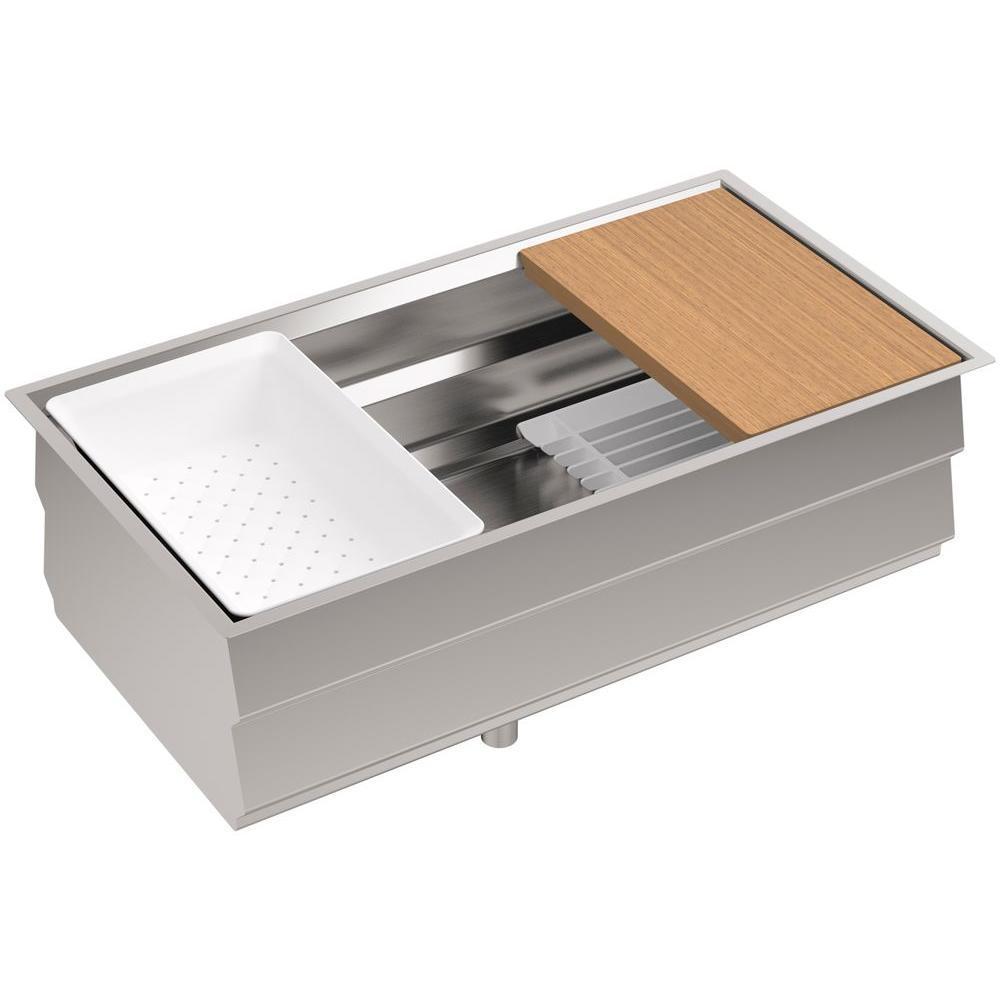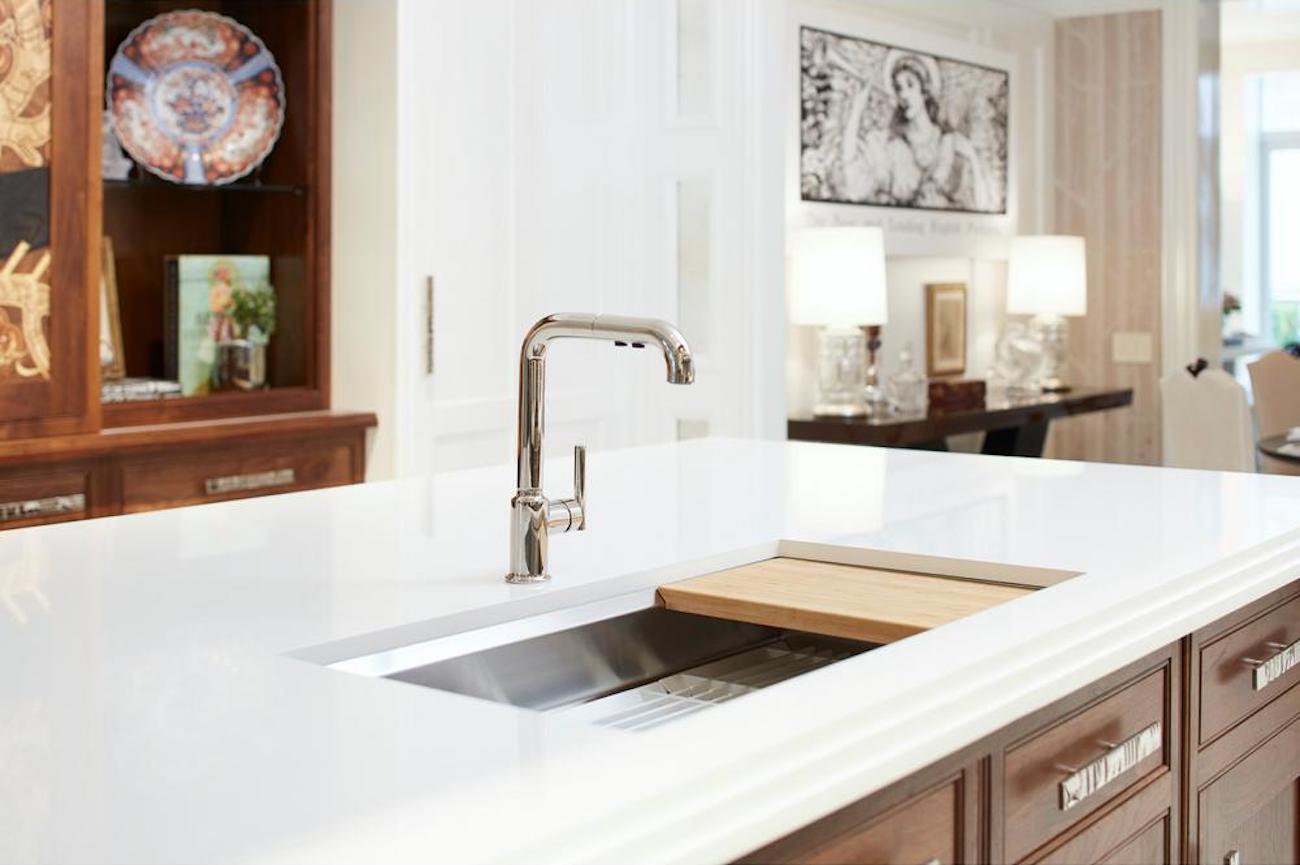The first image is the image on the left, the second image is the image on the right. Examine the images to the left and right. Is the description "A lemon sits on a white rack near the sink in one of the images." accurate? Answer yes or no. No. The first image is the image on the left, the second image is the image on the right. Evaluate the accuracy of this statement regarding the images: "A bottle is being filled with water from a faucet in the left image.". Is it true? Answer yes or no. No. 